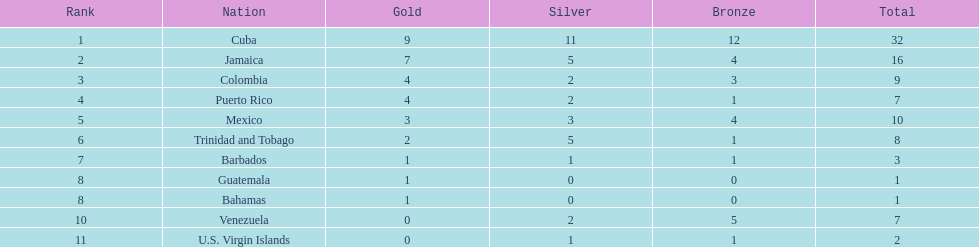Which group obtained four golden awards and one third-place prize? Puerto Rico. 